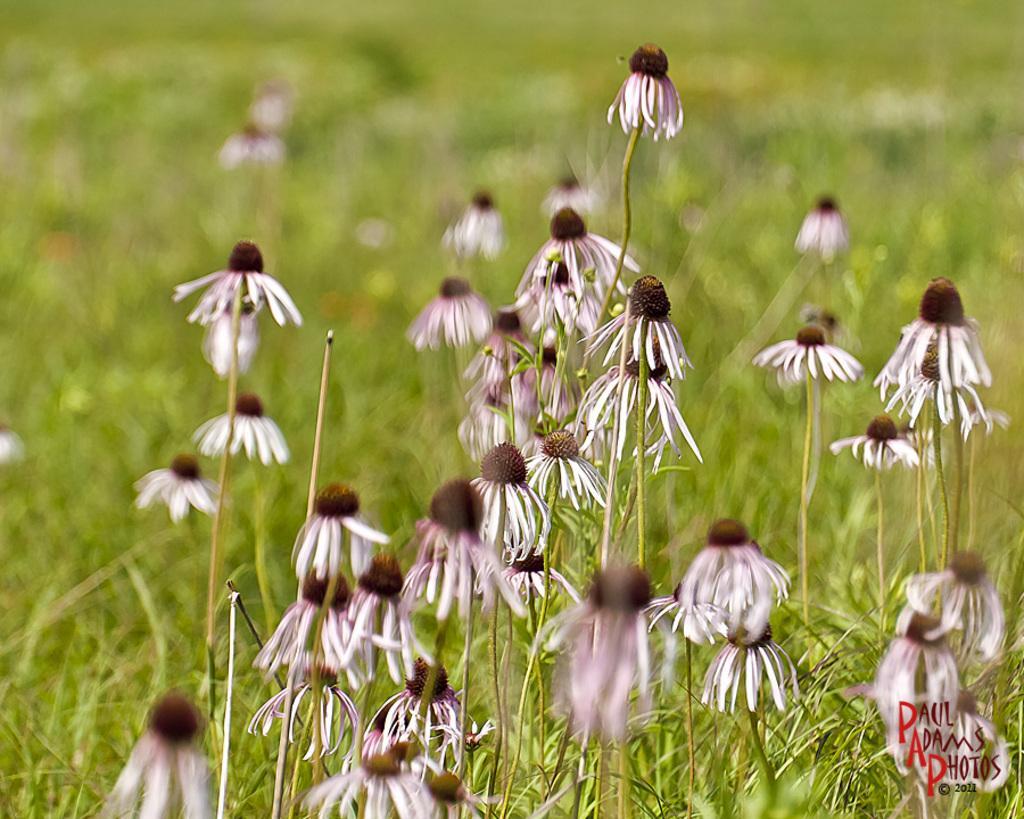Describe this image in one or two sentences. In this image we can see some flowers on the plants, and the background is blurred, at the bottom of the image we can see some text. 